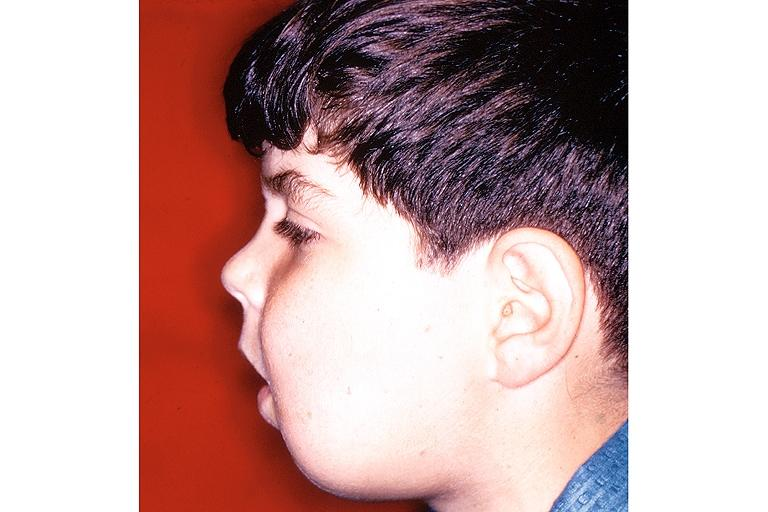does outside adrenal capsule section show cherubism?
Answer the question using a single word or phrase. No 